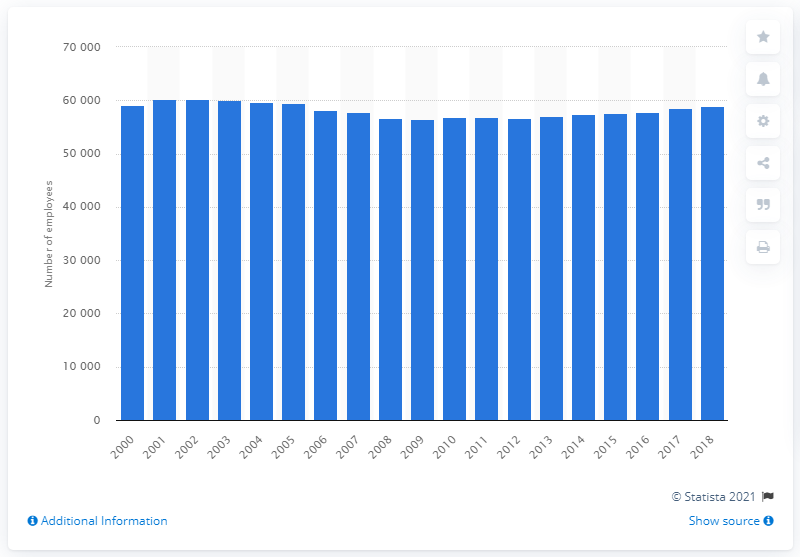Point out several critical features in this image. In 2018, there were approximately 58,940 general practitioners employed in Germany. 